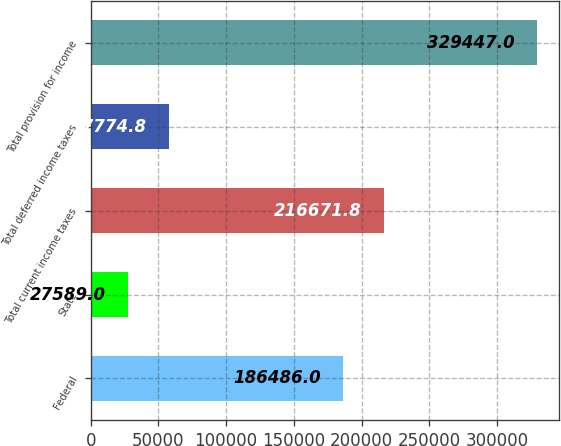Convert chart to OTSL. <chart><loc_0><loc_0><loc_500><loc_500><bar_chart><fcel>Federal<fcel>State<fcel>Total current income taxes<fcel>Total deferred income taxes<fcel>Total provision for income<nl><fcel>186486<fcel>27589<fcel>216672<fcel>57774.8<fcel>329447<nl></chart> 